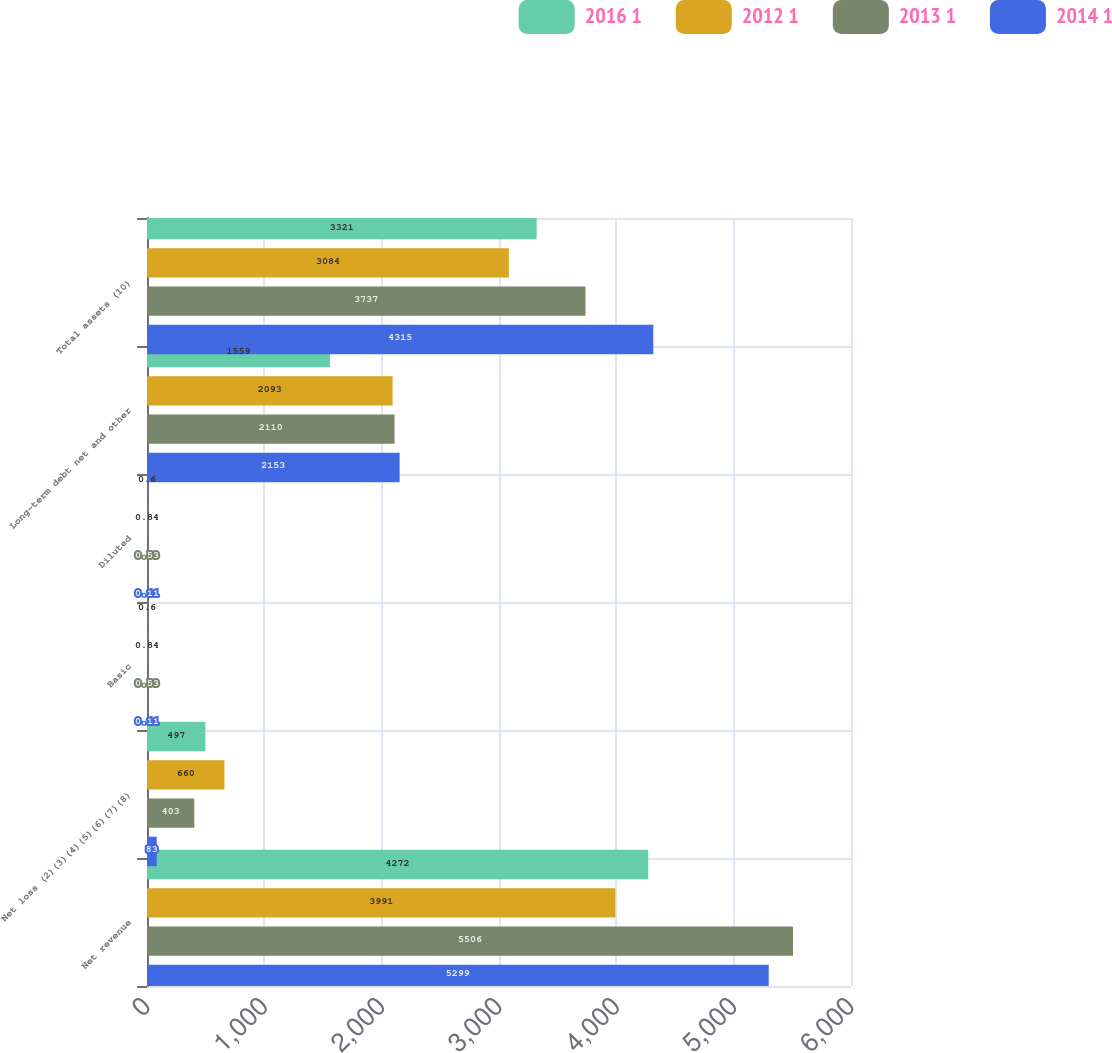Convert chart. <chart><loc_0><loc_0><loc_500><loc_500><stacked_bar_chart><ecel><fcel>Net revenue<fcel>Net loss (2)(3)(4)(5)(6)(7)(8)<fcel>Basic<fcel>Diluted<fcel>Long-term debt net and other<fcel>Total assets (10)<nl><fcel>2016 1<fcel>4272<fcel>497<fcel>0.6<fcel>0.6<fcel>1559<fcel>3321<nl><fcel>2012 1<fcel>3991<fcel>660<fcel>0.84<fcel>0.84<fcel>2093<fcel>3084<nl><fcel>2013 1<fcel>5506<fcel>403<fcel>0.53<fcel>0.53<fcel>2110<fcel>3737<nl><fcel>2014 1<fcel>5299<fcel>83<fcel>0.11<fcel>0.11<fcel>2153<fcel>4315<nl></chart> 